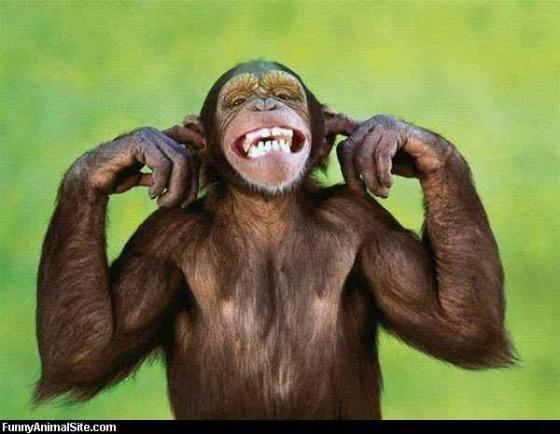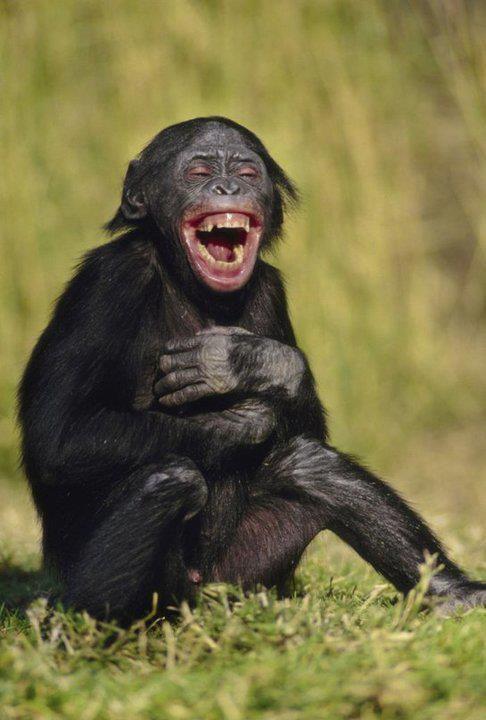The first image is the image on the left, the second image is the image on the right. For the images displayed, is the sentence "There are at most two chimpanzees." factually correct? Answer yes or no. Yes. The first image is the image on the left, the second image is the image on the right. Assess this claim about the two images: "One image in each pair has at least one chimpanzee hugging another one.". Correct or not? Answer yes or no. No. 